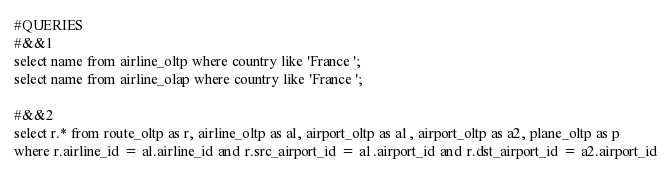Convert code to text. <code><loc_0><loc_0><loc_500><loc_500><_SQL_>#QUERIES
#&&1
select name from airline_oltp where country like 'France ';
select name from airline_olap where country like 'France ';

#&&2
select r.* from route_oltp as r, airline_oltp as al, airport_oltp as a1, airport_oltp as a2, plane_oltp as p
where r.airline_id = al.airline_id and r.src_airport_id = a1.airport_id and r.dst_airport_id = a2.airport_id</code> 